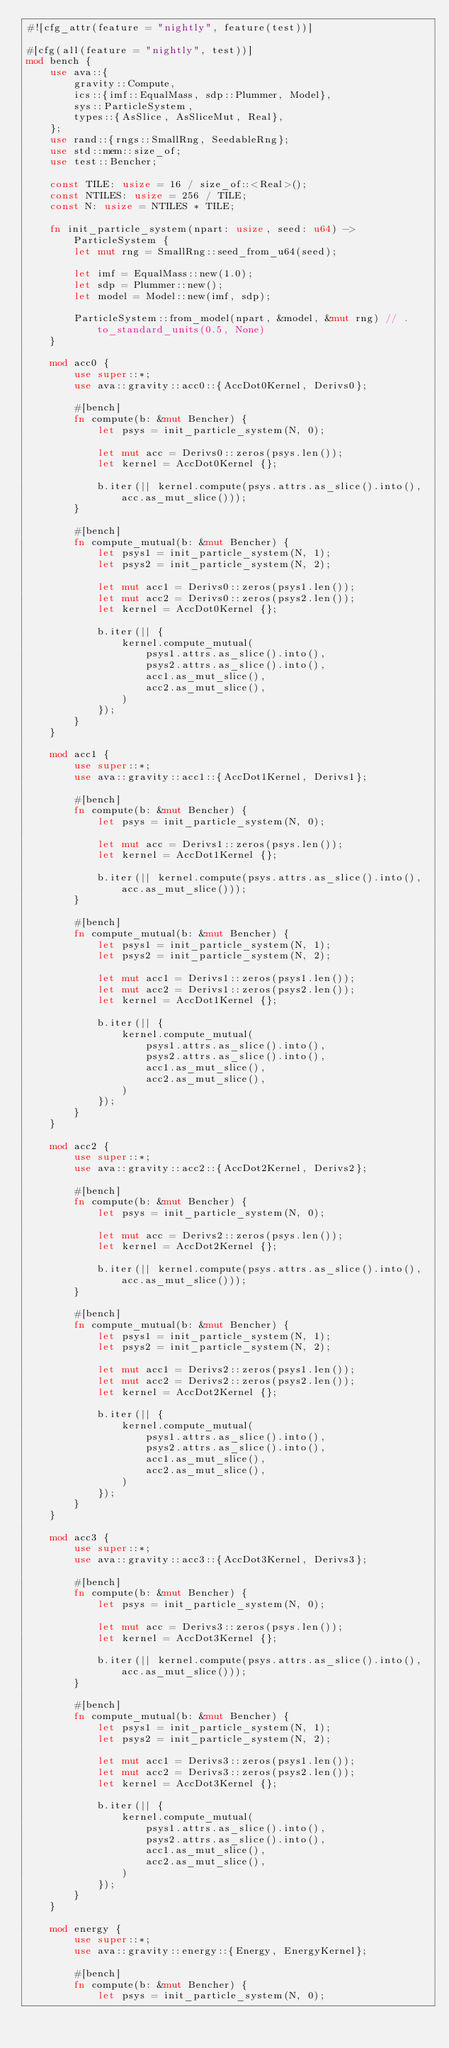Convert code to text. <code><loc_0><loc_0><loc_500><loc_500><_Rust_>#![cfg_attr(feature = "nightly", feature(test))]

#[cfg(all(feature = "nightly", test))]
mod bench {
    use ava::{
        gravity::Compute,
        ics::{imf::EqualMass, sdp::Plummer, Model},
        sys::ParticleSystem,
        types::{AsSlice, AsSliceMut, Real},
    };
    use rand::{rngs::SmallRng, SeedableRng};
    use std::mem::size_of;
    use test::Bencher;

    const TILE: usize = 16 / size_of::<Real>();
    const NTILES: usize = 256 / TILE;
    const N: usize = NTILES * TILE;

    fn init_particle_system(npart: usize, seed: u64) -> ParticleSystem {
        let mut rng = SmallRng::seed_from_u64(seed);

        let imf = EqualMass::new(1.0);
        let sdp = Plummer::new();
        let model = Model::new(imf, sdp);

        ParticleSystem::from_model(npart, &model, &mut rng) // .to_standard_units(0.5, None)
    }

    mod acc0 {
        use super::*;
        use ava::gravity::acc0::{AccDot0Kernel, Derivs0};

        #[bench]
        fn compute(b: &mut Bencher) {
            let psys = init_particle_system(N, 0);

            let mut acc = Derivs0::zeros(psys.len());
            let kernel = AccDot0Kernel {};

            b.iter(|| kernel.compute(psys.attrs.as_slice().into(), acc.as_mut_slice()));
        }

        #[bench]
        fn compute_mutual(b: &mut Bencher) {
            let psys1 = init_particle_system(N, 1);
            let psys2 = init_particle_system(N, 2);

            let mut acc1 = Derivs0::zeros(psys1.len());
            let mut acc2 = Derivs0::zeros(psys2.len());
            let kernel = AccDot0Kernel {};

            b.iter(|| {
                kernel.compute_mutual(
                    psys1.attrs.as_slice().into(),
                    psys2.attrs.as_slice().into(),
                    acc1.as_mut_slice(),
                    acc2.as_mut_slice(),
                )
            });
        }
    }

    mod acc1 {
        use super::*;
        use ava::gravity::acc1::{AccDot1Kernel, Derivs1};

        #[bench]
        fn compute(b: &mut Bencher) {
            let psys = init_particle_system(N, 0);

            let mut acc = Derivs1::zeros(psys.len());
            let kernel = AccDot1Kernel {};

            b.iter(|| kernel.compute(psys.attrs.as_slice().into(), acc.as_mut_slice()));
        }

        #[bench]
        fn compute_mutual(b: &mut Bencher) {
            let psys1 = init_particle_system(N, 1);
            let psys2 = init_particle_system(N, 2);

            let mut acc1 = Derivs1::zeros(psys1.len());
            let mut acc2 = Derivs1::zeros(psys2.len());
            let kernel = AccDot1Kernel {};

            b.iter(|| {
                kernel.compute_mutual(
                    psys1.attrs.as_slice().into(),
                    psys2.attrs.as_slice().into(),
                    acc1.as_mut_slice(),
                    acc2.as_mut_slice(),
                )
            });
        }
    }

    mod acc2 {
        use super::*;
        use ava::gravity::acc2::{AccDot2Kernel, Derivs2};

        #[bench]
        fn compute(b: &mut Bencher) {
            let psys = init_particle_system(N, 0);

            let mut acc = Derivs2::zeros(psys.len());
            let kernel = AccDot2Kernel {};

            b.iter(|| kernel.compute(psys.attrs.as_slice().into(), acc.as_mut_slice()));
        }

        #[bench]
        fn compute_mutual(b: &mut Bencher) {
            let psys1 = init_particle_system(N, 1);
            let psys2 = init_particle_system(N, 2);

            let mut acc1 = Derivs2::zeros(psys1.len());
            let mut acc2 = Derivs2::zeros(psys2.len());
            let kernel = AccDot2Kernel {};

            b.iter(|| {
                kernel.compute_mutual(
                    psys1.attrs.as_slice().into(),
                    psys2.attrs.as_slice().into(),
                    acc1.as_mut_slice(),
                    acc2.as_mut_slice(),
                )
            });
        }
    }

    mod acc3 {
        use super::*;
        use ava::gravity::acc3::{AccDot3Kernel, Derivs3};

        #[bench]
        fn compute(b: &mut Bencher) {
            let psys = init_particle_system(N, 0);

            let mut acc = Derivs3::zeros(psys.len());
            let kernel = AccDot3Kernel {};

            b.iter(|| kernel.compute(psys.attrs.as_slice().into(), acc.as_mut_slice()));
        }

        #[bench]
        fn compute_mutual(b: &mut Bencher) {
            let psys1 = init_particle_system(N, 1);
            let psys2 = init_particle_system(N, 2);

            let mut acc1 = Derivs3::zeros(psys1.len());
            let mut acc2 = Derivs3::zeros(psys2.len());
            let kernel = AccDot3Kernel {};

            b.iter(|| {
                kernel.compute_mutual(
                    psys1.attrs.as_slice().into(),
                    psys2.attrs.as_slice().into(),
                    acc1.as_mut_slice(),
                    acc2.as_mut_slice(),
                )
            });
        }
    }

    mod energy {
        use super::*;
        use ava::gravity::energy::{Energy, EnergyKernel};

        #[bench]
        fn compute(b: &mut Bencher) {
            let psys = init_particle_system(N, 0);
</code> 